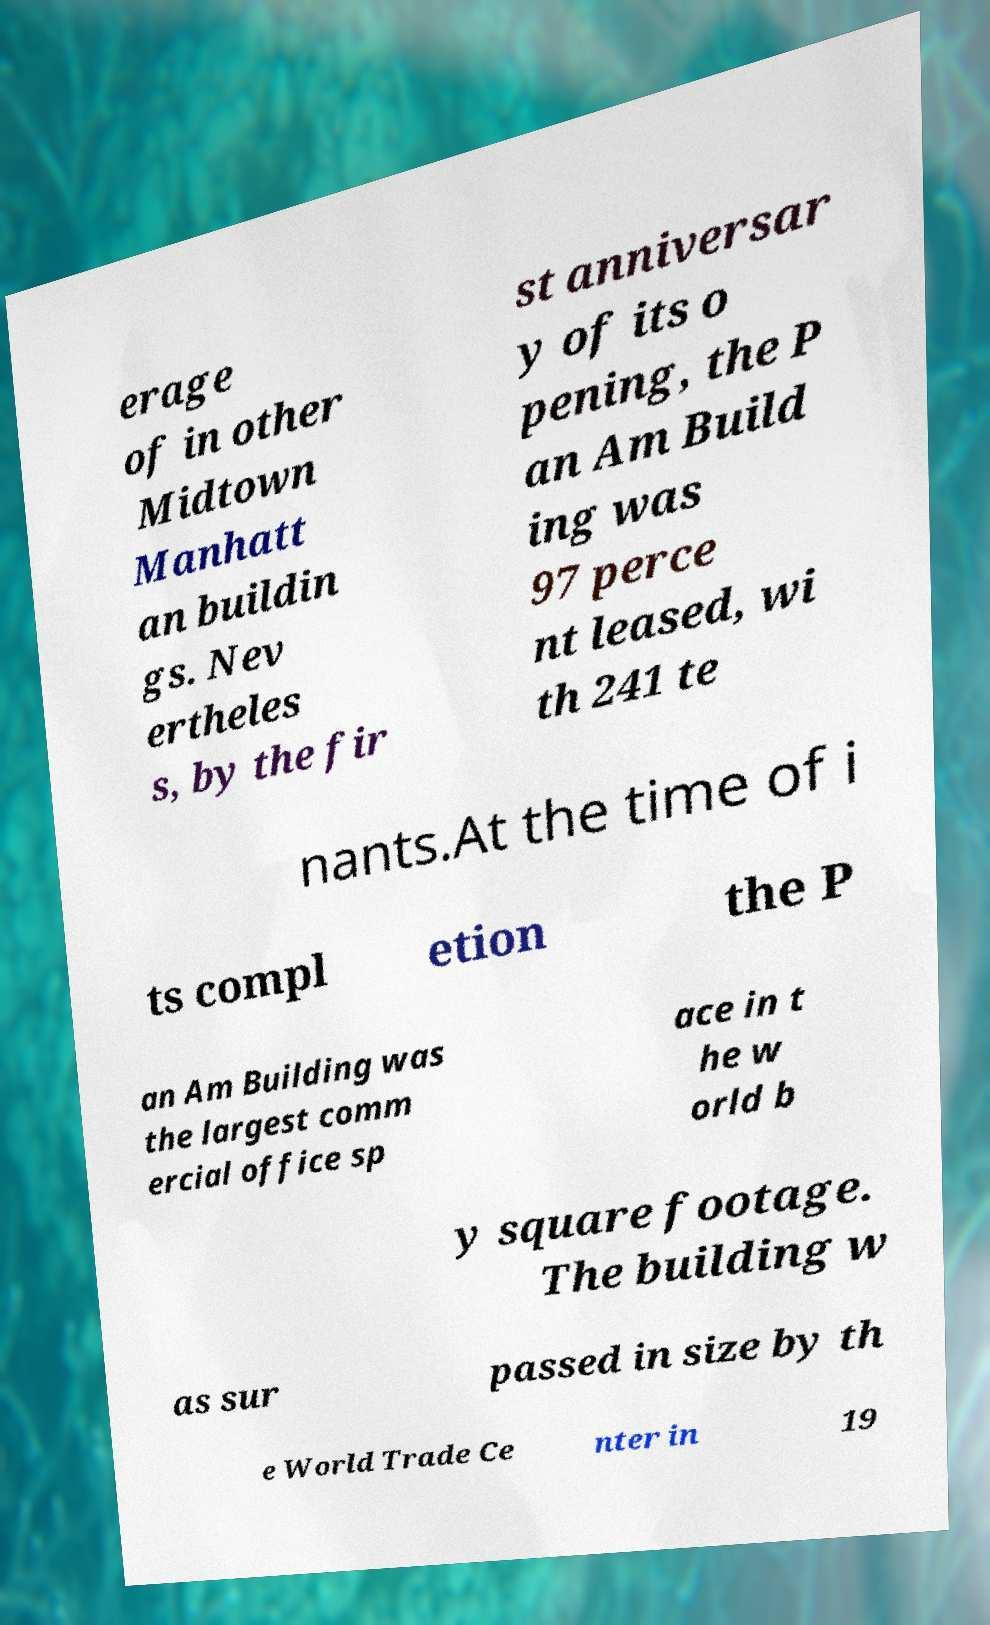For documentation purposes, I need the text within this image transcribed. Could you provide that? erage of in other Midtown Manhatt an buildin gs. Nev ertheles s, by the fir st anniversar y of its o pening, the P an Am Build ing was 97 perce nt leased, wi th 241 te nants.At the time of i ts compl etion the P an Am Building was the largest comm ercial office sp ace in t he w orld b y square footage. The building w as sur passed in size by th e World Trade Ce nter in 19 